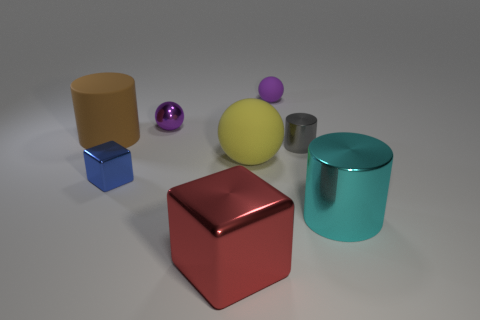Subtract all large cylinders. How many cylinders are left? 1 Add 1 green shiny balls. How many objects exist? 9 Subtract all spheres. How many objects are left? 5 Subtract all blue blocks. How many blocks are left? 1 Subtract 3 balls. How many balls are left? 0 Subtract all gray cylinders. How many purple balls are left? 2 Subtract all cyan cylinders. Subtract all brown objects. How many objects are left? 6 Add 6 big yellow spheres. How many big yellow spheres are left? 7 Add 5 brown matte cylinders. How many brown matte cylinders exist? 6 Subtract 1 blue cubes. How many objects are left? 7 